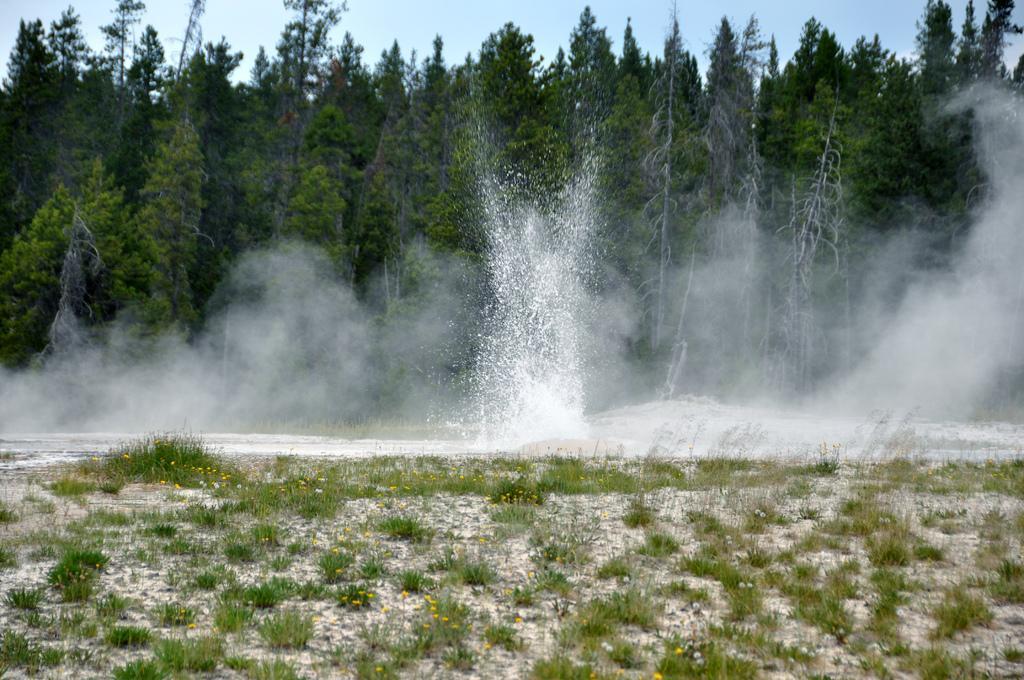Describe this image in one or two sentences. In this image I can see grass ground in the front. In the background I can see water, smoke, number of trees and the sky. 